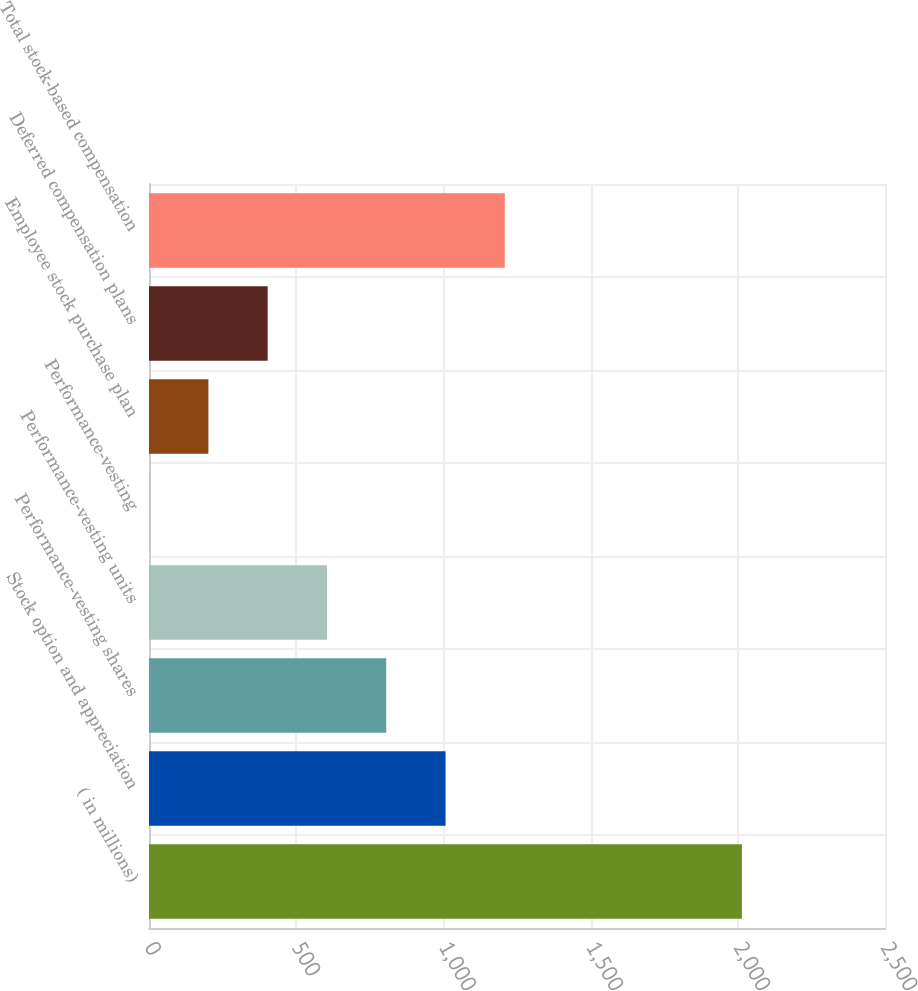Convert chart to OTSL. <chart><loc_0><loc_0><loc_500><loc_500><bar_chart><fcel>( in millions)<fcel>Stock option and appreciation<fcel>Performance-vesting shares<fcel>Performance-vesting units<fcel>Performance-vesting<fcel>Employee stock purchase plan<fcel>Deferred compensation plans<fcel>Total stock-based compensation<nl><fcel>2014<fcel>1007.2<fcel>805.84<fcel>604.48<fcel>0.4<fcel>201.76<fcel>403.12<fcel>1208.56<nl></chart> 